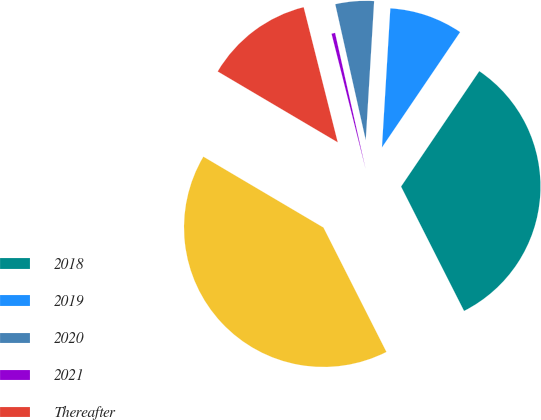Convert chart. <chart><loc_0><loc_0><loc_500><loc_500><pie_chart><fcel>2018<fcel>2019<fcel>2020<fcel>2021<fcel>Thereafter<fcel>Total<nl><fcel>33.06%<fcel>8.52%<fcel>4.47%<fcel>0.42%<fcel>12.58%<fcel>40.95%<nl></chart> 